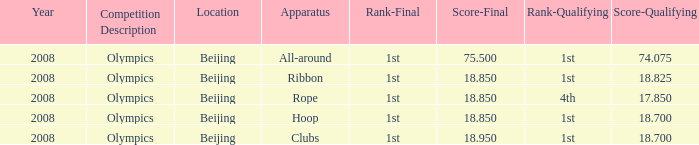On which apparatus did Kanayeva have a final score smaller than 75.5 and a qualifying score smaller than 18.7? Rope. 